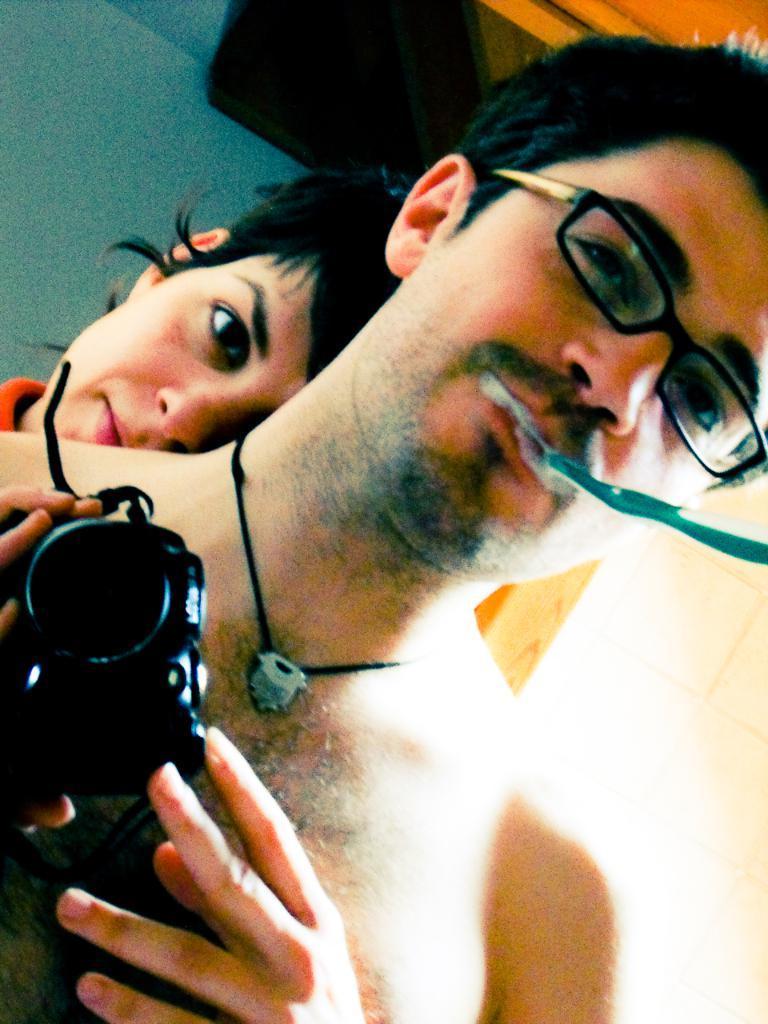Could you give a brief overview of what you see in this image? This picture shows a man standing holding a camera in his hands and we see a toothbrush in his mouth and spectacles on his face and we see a woman standing on the back. 